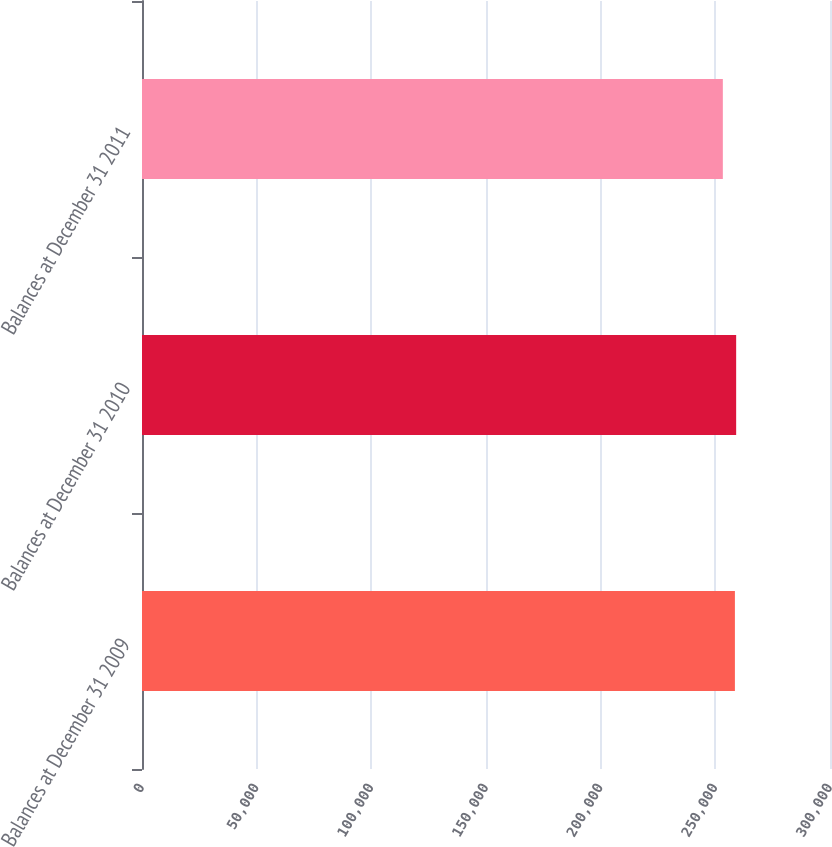Convert chart. <chart><loc_0><loc_0><loc_500><loc_500><bar_chart><fcel>Balances at December 31 2009<fcel>Balances at December 31 2010<fcel>Balances at December 31 2011<nl><fcel>258534<fcel>259083<fcel>253272<nl></chart> 